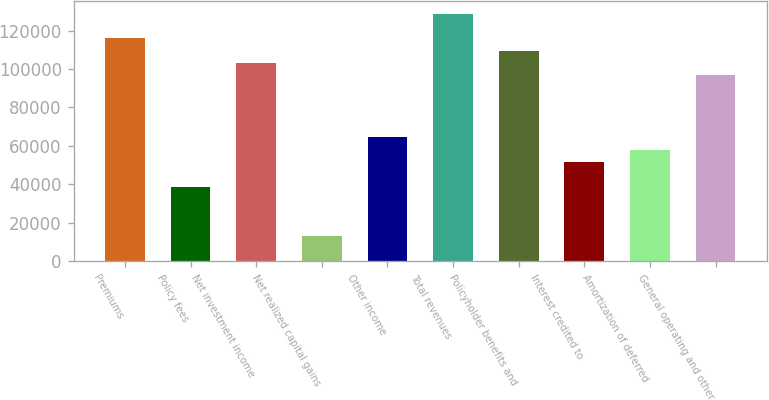Convert chart. <chart><loc_0><loc_0><loc_500><loc_500><bar_chart><fcel>Premiums<fcel>Policy fees<fcel>Net investment income<fcel>Net realized capital gains<fcel>Other income<fcel>Total revenues<fcel>Policyholder benefits and<fcel>Interest credited to<fcel>Amortization of deferred<fcel>General operating and other<nl><fcel>115930<fcel>38643.8<fcel>103049<fcel>12881.6<fcel>64406<fcel>128812<fcel>109490<fcel>51524.9<fcel>57965.4<fcel>96608.8<nl></chart> 